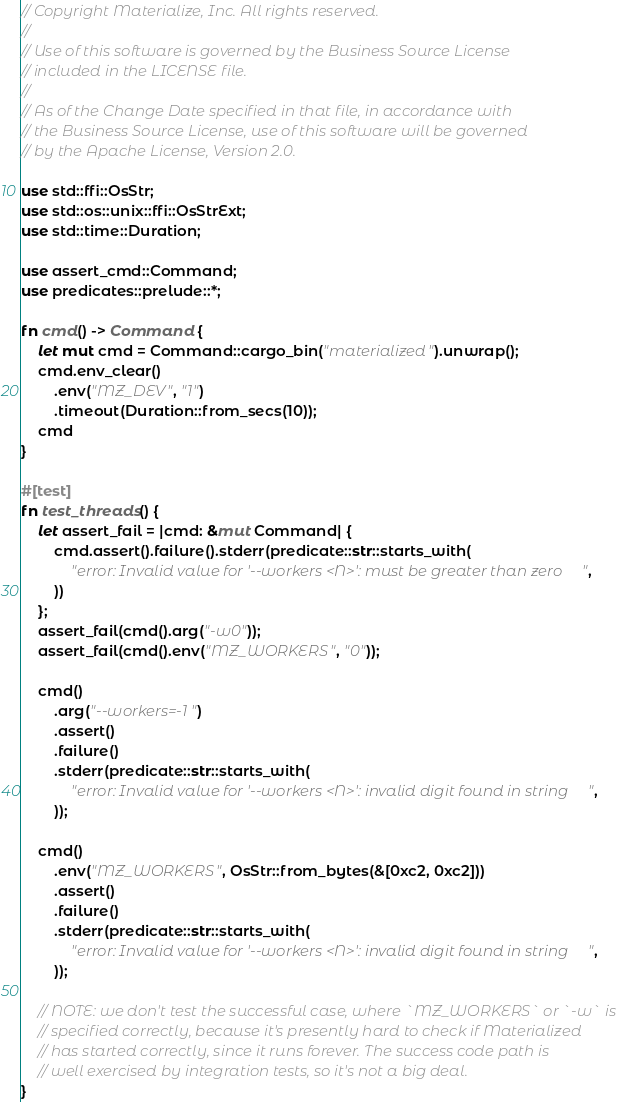<code> <loc_0><loc_0><loc_500><loc_500><_Rust_>// Copyright Materialize, Inc. All rights reserved.
//
// Use of this software is governed by the Business Source License
// included in the LICENSE file.
//
// As of the Change Date specified in that file, in accordance with
// the Business Source License, use of this software will be governed
// by the Apache License, Version 2.0.

use std::ffi::OsStr;
use std::os::unix::ffi::OsStrExt;
use std::time::Duration;

use assert_cmd::Command;
use predicates::prelude::*;

fn cmd() -> Command {
    let mut cmd = Command::cargo_bin("materialized").unwrap();
    cmd.env_clear()
        .env("MZ_DEV", "1")
        .timeout(Duration::from_secs(10));
    cmd
}

#[test]
fn test_threads() {
    let assert_fail = |cmd: &mut Command| {
        cmd.assert().failure().stderr(predicate::str::starts_with(
            "error: Invalid value for '--workers <N>': must be greater than zero",
        ))
    };
    assert_fail(cmd().arg("-w0"));
    assert_fail(cmd().env("MZ_WORKERS", "0"));

    cmd()
        .arg("--workers=-1")
        .assert()
        .failure()
        .stderr(predicate::str::starts_with(
            "error: Invalid value for '--workers <N>': invalid digit found in string",
        ));

    cmd()
        .env("MZ_WORKERS", OsStr::from_bytes(&[0xc2, 0xc2]))
        .assert()
        .failure()
        .stderr(predicate::str::starts_with(
            "error: Invalid value for '--workers <N>': invalid digit found in string",
        ));

    // NOTE: we don't test the successful case, where `MZ_WORKERS` or `-w` is
    // specified correctly, because it's presently hard to check if Materialized
    // has started correctly, since it runs forever. The success code path is
    // well exercised by integration tests, so it's not a big deal.
}
</code> 